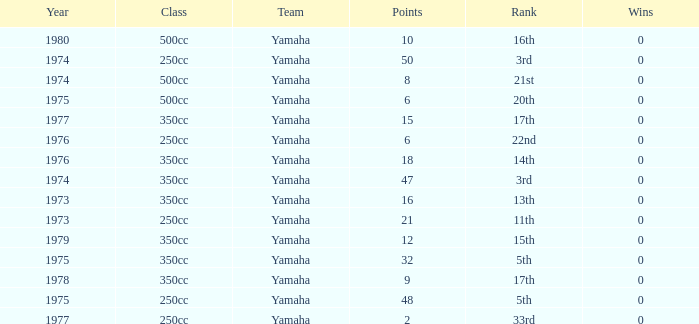Which Wins is the highest one that has a Class of 500cc, and Points smaller than 6? None. 